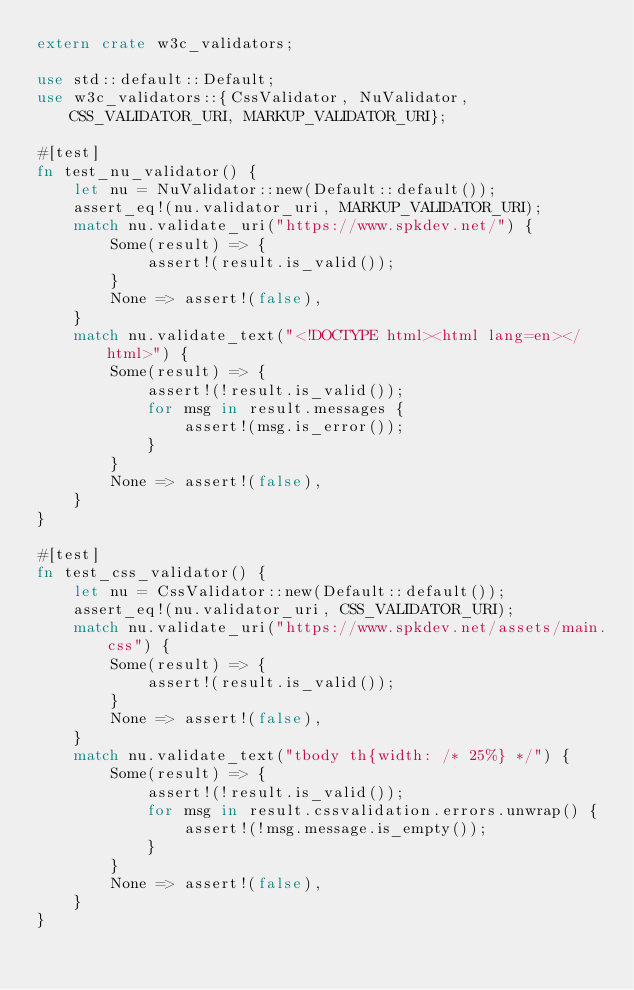Convert code to text. <code><loc_0><loc_0><loc_500><loc_500><_Rust_>extern crate w3c_validators;

use std::default::Default;
use w3c_validators::{CssValidator, NuValidator, CSS_VALIDATOR_URI, MARKUP_VALIDATOR_URI};

#[test]
fn test_nu_validator() {
    let nu = NuValidator::new(Default::default());
    assert_eq!(nu.validator_uri, MARKUP_VALIDATOR_URI);
    match nu.validate_uri("https://www.spkdev.net/") {
        Some(result) => {
            assert!(result.is_valid());
        }
        None => assert!(false),
    }
    match nu.validate_text("<!DOCTYPE html><html lang=en></html>") {
        Some(result) => {
            assert!(!result.is_valid());
            for msg in result.messages {
                assert!(msg.is_error());
            }
        }
        None => assert!(false),
    }
}

#[test]
fn test_css_validator() {
    let nu = CssValidator::new(Default::default());
    assert_eq!(nu.validator_uri, CSS_VALIDATOR_URI);
    match nu.validate_uri("https://www.spkdev.net/assets/main.css") {
        Some(result) => {
            assert!(result.is_valid());
        }
        None => assert!(false),
    }
    match nu.validate_text("tbody th{width: /* 25%} */") {
        Some(result) => {
            assert!(!result.is_valid());
            for msg in result.cssvalidation.errors.unwrap() {
                assert!(!msg.message.is_empty());
            }
        }
        None => assert!(false),
    }
}
</code> 